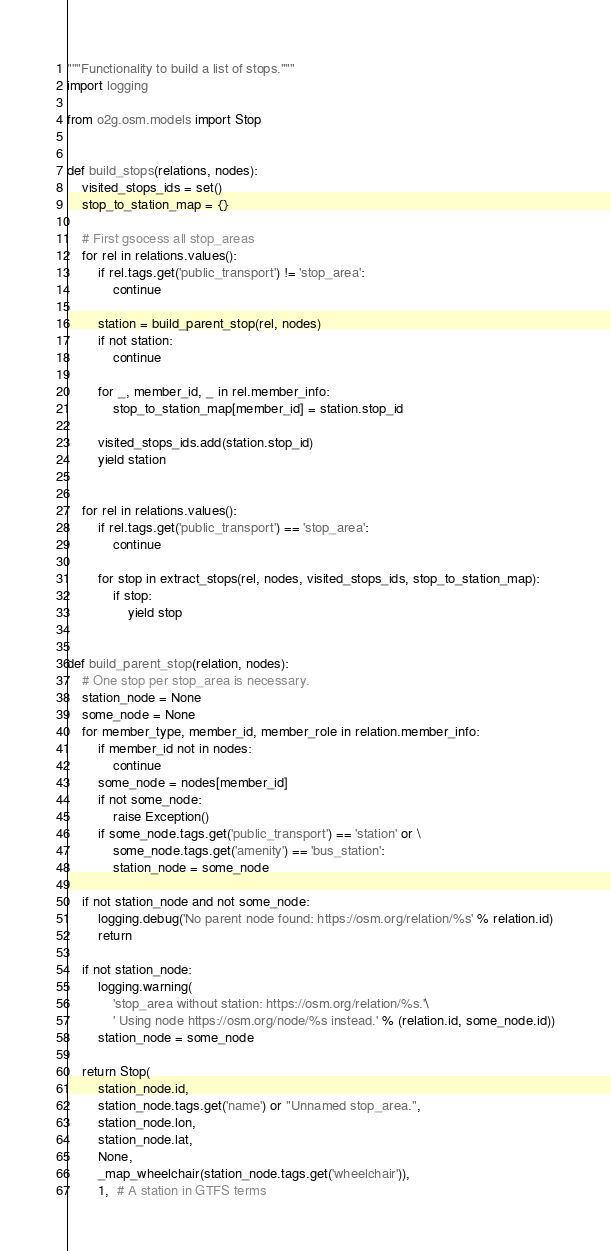Convert code to text. <code><loc_0><loc_0><loc_500><loc_500><_Python_>"""Functionality to build a list of stops."""
import logging

from o2g.osm.models import Stop


def build_stops(relations, nodes):
    visited_stops_ids = set()
    stop_to_station_map = {}

    # First gsocess all stop_areas
    for rel in relations.values():
        if rel.tags.get('public_transport') != 'stop_area':
            continue

        station = build_parent_stop(rel, nodes)
        if not station:
            continue

        for _, member_id, _ in rel.member_info:
            stop_to_station_map[member_id] = station.stop_id

        visited_stops_ids.add(station.stop_id)
        yield station


    for rel in relations.values():
        if rel.tags.get('public_transport') == 'stop_area':
            continue

        for stop in extract_stops(rel, nodes, visited_stops_ids, stop_to_station_map):
            if stop:
                yield stop


def build_parent_stop(relation, nodes):
    # One stop per stop_area is necessary.
    station_node = None
    some_node = None
    for member_type, member_id, member_role in relation.member_info:
        if member_id not in nodes:
            continue
        some_node = nodes[member_id]
        if not some_node:
            raise Exception()
        if some_node.tags.get('public_transport') == 'station' or \
            some_node.tags.get('amenity') == 'bus_station':
            station_node = some_node

    if not station_node and not some_node:
        logging.debug('No parent node found: https://osm.org/relation/%s' % relation.id)
        return

    if not station_node:
        logging.warning(
            'stop_area without station: https://osm.org/relation/%s.'\
            ' Using node https://osm.org/node/%s instead.' % (relation.id, some_node.id))
        station_node = some_node

    return Stop(
        station_node.id,
        station_node.tags.get('name') or "Unnamed stop_area.",
        station_node.lon,
        station_node.lat,
        None,
        _map_wheelchair(station_node.tags.get('wheelchair')),
        1,  # A station in GTFS terms</code> 